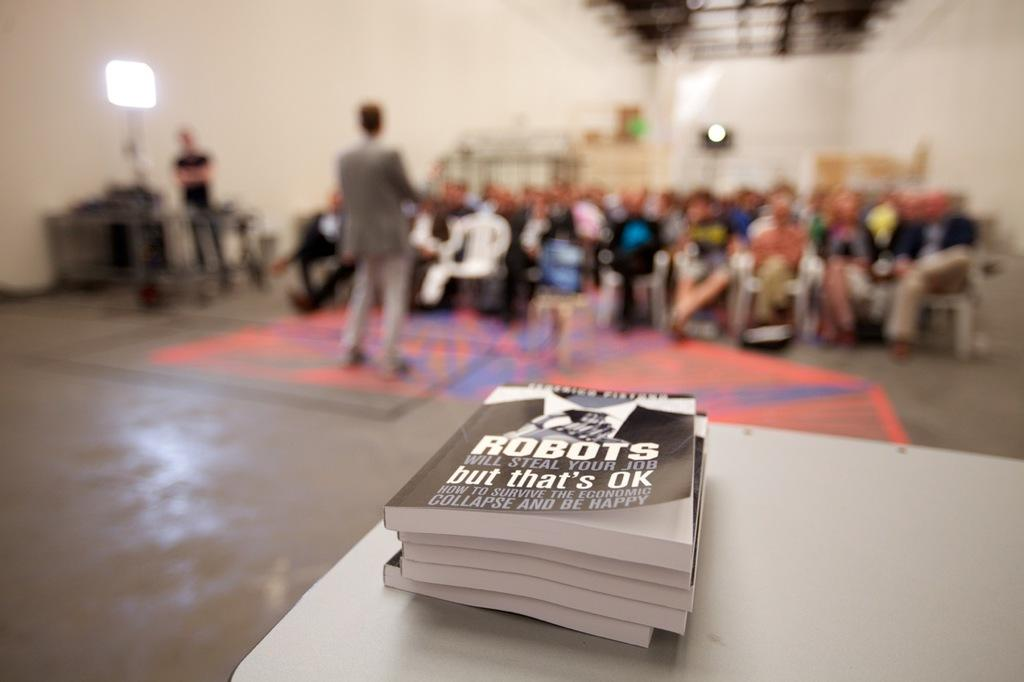<image>
Present a compact description of the photo's key features. A book about robots sits in a stack on a table. 